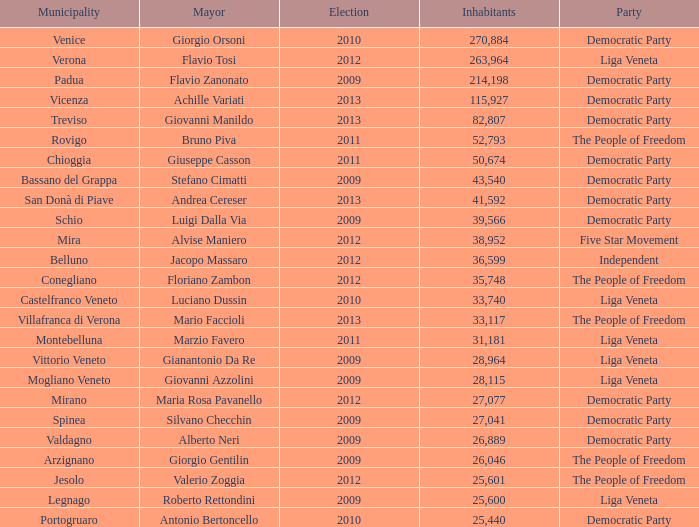How many Inhabitants were in the democratic party for an election before 2009 for Mayor of stefano cimatti? 0.0. 